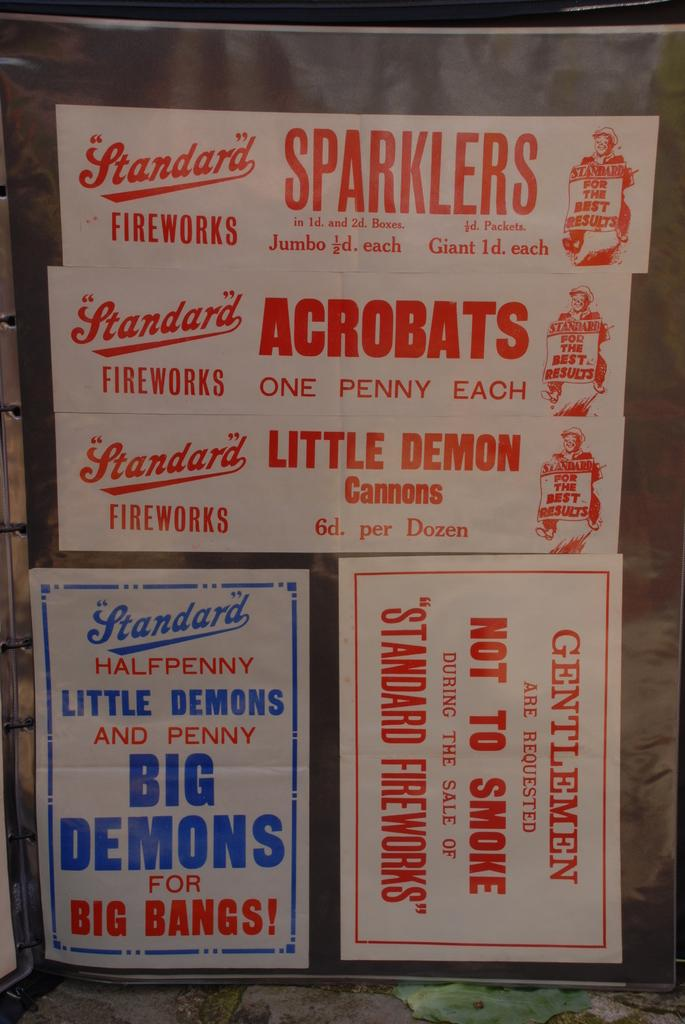Provide a one-sentence caption for the provided image. Stickers advertise Standard fireworks and sparklers in red letters. 